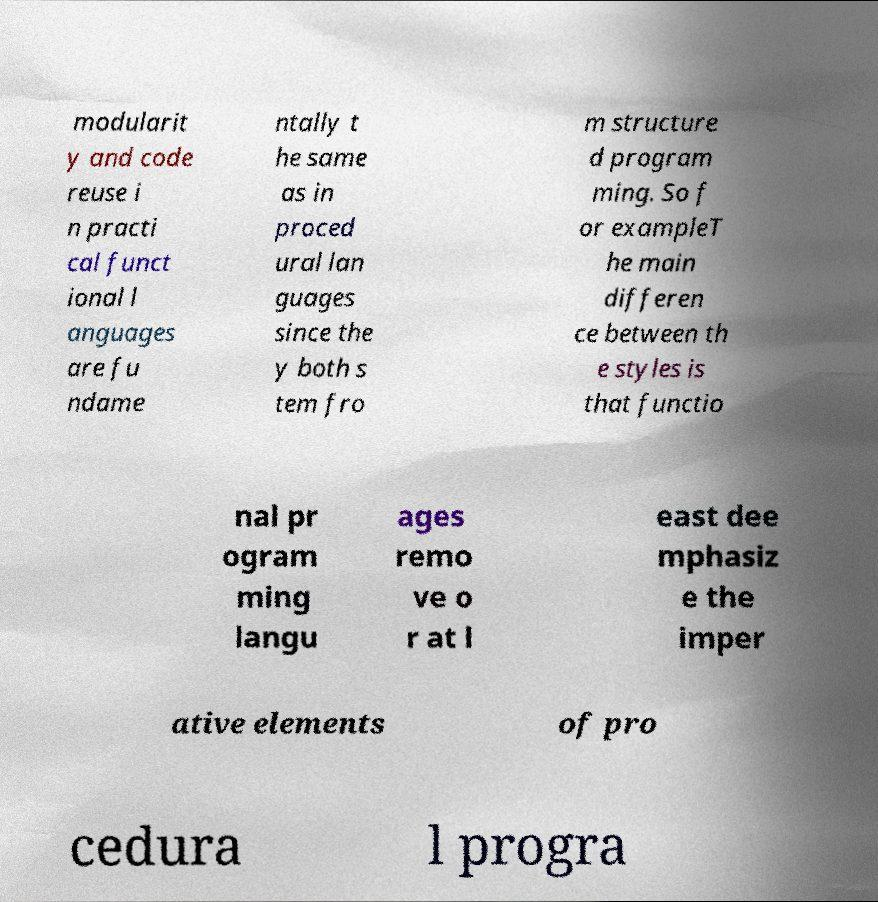Could you extract and type out the text from this image? modularit y and code reuse i n practi cal funct ional l anguages are fu ndame ntally t he same as in proced ural lan guages since the y both s tem fro m structure d program ming. So f or exampleT he main differen ce between th e styles is that functio nal pr ogram ming langu ages remo ve o r at l east dee mphasiz e the imper ative elements of pro cedura l progra 